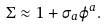<formula> <loc_0><loc_0><loc_500><loc_500>\Sigma \approx 1 + \sigma _ { a } \varphi ^ { a } .</formula> 